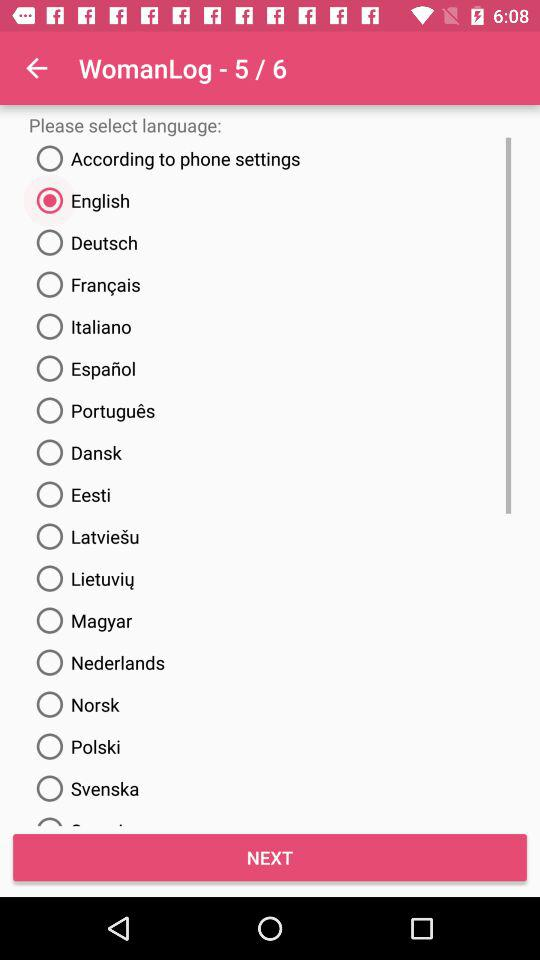At which "WomanLog" currently are we? You are currently on "WomanLog" 5. 